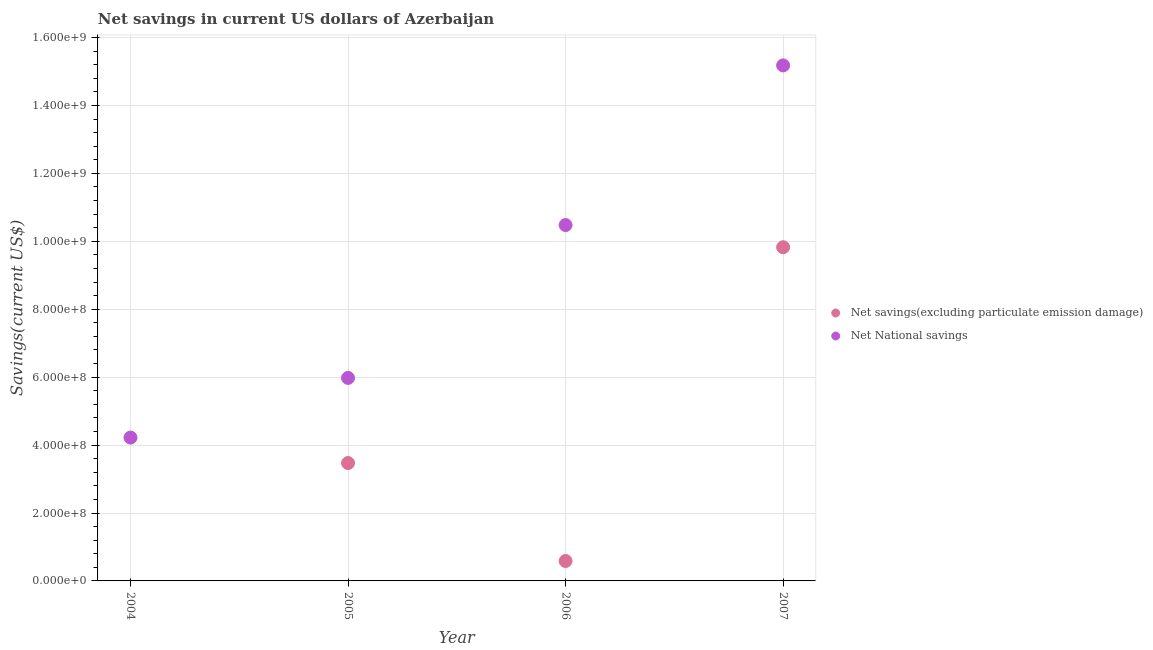How many different coloured dotlines are there?
Your response must be concise. 2. What is the net national savings in 2006?
Ensure brevity in your answer.  1.05e+09. Across all years, what is the maximum net national savings?
Offer a very short reply. 1.52e+09. Across all years, what is the minimum net savings(excluding particulate emission damage)?
Your response must be concise. 0. What is the total net savings(excluding particulate emission damage) in the graph?
Make the answer very short. 1.39e+09. What is the difference between the net savings(excluding particulate emission damage) in 2005 and that in 2007?
Keep it short and to the point. -6.36e+08. What is the difference between the net savings(excluding particulate emission damage) in 2005 and the net national savings in 2004?
Make the answer very short. -7.49e+07. What is the average net savings(excluding particulate emission damage) per year?
Your answer should be very brief. 3.47e+08. In the year 2007, what is the difference between the net savings(excluding particulate emission damage) and net national savings?
Offer a very short reply. -5.35e+08. In how many years, is the net national savings greater than 1080000000 US$?
Provide a short and direct response. 1. What is the ratio of the net savings(excluding particulate emission damage) in 2005 to that in 2006?
Ensure brevity in your answer.  5.92. Is the net national savings in 2005 less than that in 2007?
Provide a succinct answer. Yes. What is the difference between the highest and the second highest net national savings?
Your answer should be compact. 4.70e+08. What is the difference between the highest and the lowest net national savings?
Provide a succinct answer. 1.10e+09. Is the sum of the net savings(excluding particulate emission damage) in 2005 and 2006 greater than the maximum net national savings across all years?
Give a very brief answer. No. Does the net savings(excluding particulate emission damage) monotonically increase over the years?
Ensure brevity in your answer.  No. Is the net savings(excluding particulate emission damage) strictly greater than the net national savings over the years?
Provide a short and direct response. No. How many years are there in the graph?
Offer a terse response. 4. What is the difference between two consecutive major ticks on the Y-axis?
Your response must be concise. 2.00e+08. Are the values on the major ticks of Y-axis written in scientific E-notation?
Make the answer very short. Yes. Where does the legend appear in the graph?
Ensure brevity in your answer.  Center right. How are the legend labels stacked?
Your answer should be compact. Vertical. What is the title of the graph?
Provide a succinct answer. Net savings in current US dollars of Azerbaijan. What is the label or title of the Y-axis?
Keep it short and to the point. Savings(current US$). What is the Savings(current US$) in Net savings(excluding particulate emission damage) in 2004?
Ensure brevity in your answer.  0. What is the Savings(current US$) of Net National savings in 2004?
Your answer should be compact. 4.22e+08. What is the Savings(current US$) in Net savings(excluding particulate emission damage) in 2005?
Give a very brief answer. 3.47e+08. What is the Savings(current US$) of Net National savings in 2005?
Give a very brief answer. 5.98e+08. What is the Savings(current US$) of Net savings(excluding particulate emission damage) in 2006?
Provide a succinct answer. 5.87e+07. What is the Savings(current US$) of Net National savings in 2006?
Provide a succinct answer. 1.05e+09. What is the Savings(current US$) in Net savings(excluding particulate emission damage) in 2007?
Offer a very short reply. 9.83e+08. What is the Savings(current US$) in Net National savings in 2007?
Your answer should be very brief. 1.52e+09. Across all years, what is the maximum Savings(current US$) in Net savings(excluding particulate emission damage)?
Your answer should be compact. 9.83e+08. Across all years, what is the maximum Savings(current US$) in Net National savings?
Give a very brief answer. 1.52e+09. Across all years, what is the minimum Savings(current US$) of Net National savings?
Your answer should be compact. 4.22e+08. What is the total Savings(current US$) of Net savings(excluding particulate emission damage) in the graph?
Provide a short and direct response. 1.39e+09. What is the total Savings(current US$) in Net National savings in the graph?
Your response must be concise. 3.59e+09. What is the difference between the Savings(current US$) in Net National savings in 2004 and that in 2005?
Ensure brevity in your answer.  -1.76e+08. What is the difference between the Savings(current US$) of Net National savings in 2004 and that in 2006?
Offer a very short reply. -6.26e+08. What is the difference between the Savings(current US$) in Net National savings in 2004 and that in 2007?
Provide a short and direct response. -1.10e+09. What is the difference between the Savings(current US$) of Net savings(excluding particulate emission damage) in 2005 and that in 2006?
Give a very brief answer. 2.88e+08. What is the difference between the Savings(current US$) of Net National savings in 2005 and that in 2006?
Your response must be concise. -4.50e+08. What is the difference between the Savings(current US$) of Net savings(excluding particulate emission damage) in 2005 and that in 2007?
Offer a terse response. -6.36e+08. What is the difference between the Savings(current US$) of Net National savings in 2005 and that in 2007?
Your response must be concise. -9.20e+08. What is the difference between the Savings(current US$) of Net savings(excluding particulate emission damage) in 2006 and that in 2007?
Your response must be concise. -9.24e+08. What is the difference between the Savings(current US$) in Net National savings in 2006 and that in 2007?
Provide a succinct answer. -4.70e+08. What is the difference between the Savings(current US$) of Net savings(excluding particulate emission damage) in 2005 and the Savings(current US$) of Net National savings in 2006?
Your response must be concise. -7.01e+08. What is the difference between the Savings(current US$) in Net savings(excluding particulate emission damage) in 2005 and the Savings(current US$) in Net National savings in 2007?
Your answer should be compact. -1.17e+09. What is the difference between the Savings(current US$) of Net savings(excluding particulate emission damage) in 2006 and the Savings(current US$) of Net National savings in 2007?
Give a very brief answer. -1.46e+09. What is the average Savings(current US$) of Net savings(excluding particulate emission damage) per year?
Give a very brief answer. 3.47e+08. What is the average Savings(current US$) of Net National savings per year?
Ensure brevity in your answer.  8.96e+08. In the year 2005, what is the difference between the Savings(current US$) of Net savings(excluding particulate emission damage) and Savings(current US$) of Net National savings?
Give a very brief answer. -2.51e+08. In the year 2006, what is the difference between the Savings(current US$) in Net savings(excluding particulate emission damage) and Savings(current US$) in Net National savings?
Your answer should be very brief. -9.89e+08. In the year 2007, what is the difference between the Savings(current US$) in Net savings(excluding particulate emission damage) and Savings(current US$) in Net National savings?
Give a very brief answer. -5.35e+08. What is the ratio of the Savings(current US$) of Net National savings in 2004 to that in 2005?
Keep it short and to the point. 0.71. What is the ratio of the Savings(current US$) of Net National savings in 2004 to that in 2006?
Give a very brief answer. 0.4. What is the ratio of the Savings(current US$) of Net National savings in 2004 to that in 2007?
Give a very brief answer. 0.28. What is the ratio of the Savings(current US$) of Net savings(excluding particulate emission damage) in 2005 to that in 2006?
Ensure brevity in your answer.  5.92. What is the ratio of the Savings(current US$) of Net National savings in 2005 to that in 2006?
Make the answer very short. 0.57. What is the ratio of the Savings(current US$) in Net savings(excluding particulate emission damage) in 2005 to that in 2007?
Provide a short and direct response. 0.35. What is the ratio of the Savings(current US$) in Net National savings in 2005 to that in 2007?
Your answer should be compact. 0.39. What is the ratio of the Savings(current US$) in Net savings(excluding particulate emission damage) in 2006 to that in 2007?
Your response must be concise. 0.06. What is the ratio of the Savings(current US$) in Net National savings in 2006 to that in 2007?
Your answer should be compact. 0.69. What is the difference between the highest and the second highest Savings(current US$) in Net savings(excluding particulate emission damage)?
Keep it short and to the point. 6.36e+08. What is the difference between the highest and the second highest Savings(current US$) of Net National savings?
Ensure brevity in your answer.  4.70e+08. What is the difference between the highest and the lowest Savings(current US$) of Net savings(excluding particulate emission damage)?
Your answer should be very brief. 9.83e+08. What is the difference between the highest and the lowest Savings(current US$) of Net National savings?
Give a very brief answer. 1.10e+09. 